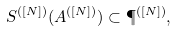Convert formula to latex. <formula><loc_0><loc_0><loc_500><loc_500>S ^ { ( [ N ] ) } ( A ^ { ( [ N ] ) } ) \subset \P ^ { ( [ N ] ) } ,</formula> 